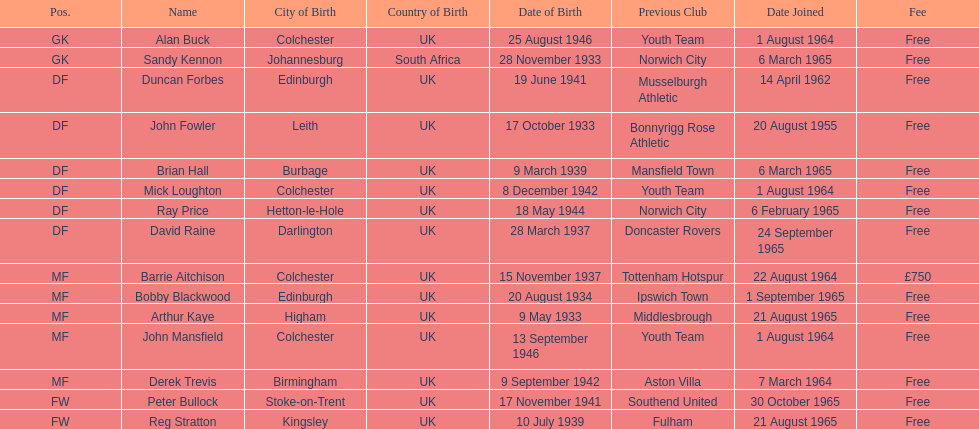Is arthur kaye older or younger than brian hill? Older. 